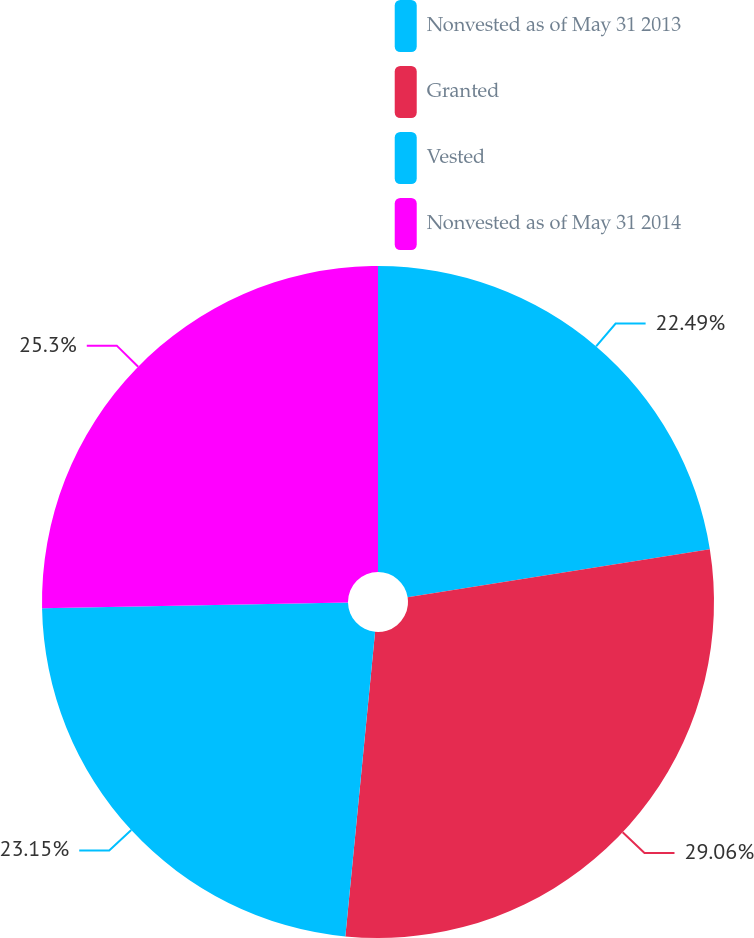<chart> <loc_0><loc_0><loc_500><loc_500><pie_chart><fcel>Nonvested as of May 31 2013<fcel>Granted<fcel>Vested<fcel>Nonvested as of May 31 2014<nl><fcel>22.49%<fcel>29.06%<fcel>23.15%<fcel>25.3%<nl></chart> 